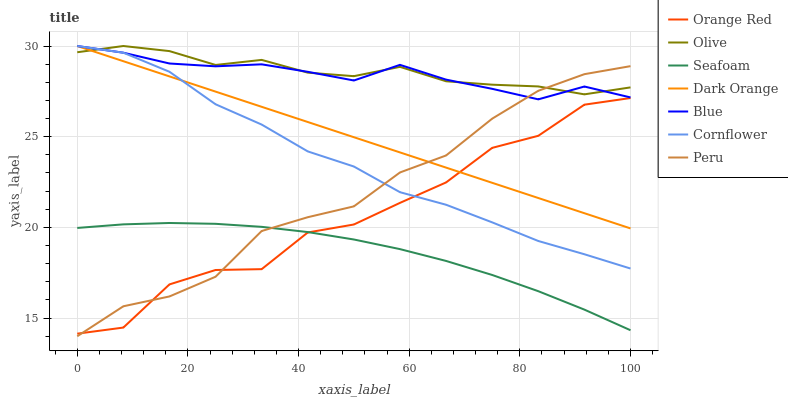Does Seafoam have the minimum area under the curve?
Answer yes or no. Yes. Does Olive have the maximum area under the curve?
Answer yes or no. Yes. Does Dark Orange have the minimum area under the curve?
Answer yes or no. No. Does Dark Orange have the maximum area under the curve?
Answer yes or no. No. Is Dark Orange the smoothest?
Answer yes or no. Yes. Is Orange Red the roughest?
Answer yes or no. Yes. Is Cornflower the smoothest?
Answer yes or no. No. Is Cornflower the roughest?
Answer yes or no. No. Does Dark Orange have the lowest value?
Answer yes or no. No. Does Seafoam have the highest value?
Answer yes or no. No. Is Seafoam less than Cornflower?
Answer yes or no. Yes. Is Blue greater than Seafoam?
Answer yes or no. Yes. Does Seafoam intersect Cornflower?
Answer yes or no. No. 